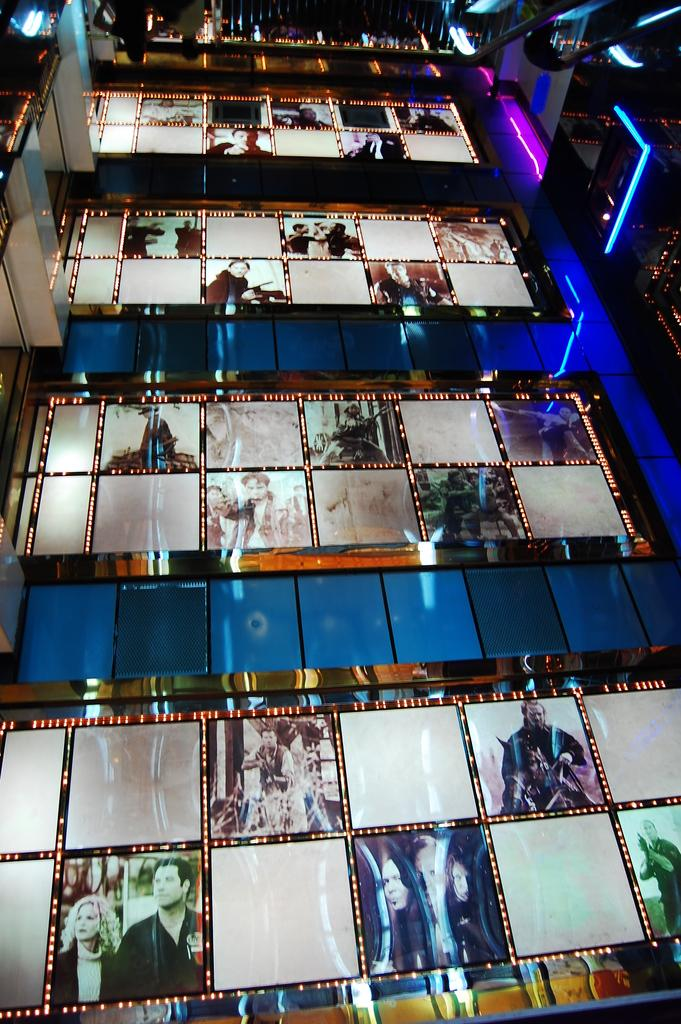What is located in the center of the image? There are photos in the center of the image. What can be seen at the top of the image? There are lights on the top of the image. What time of day is it in the image, and how does it affect the need for lights? The time of day is not mentioned in the image, and therefore it cannot be determined if the lights are needed or if it is the afternoon. 